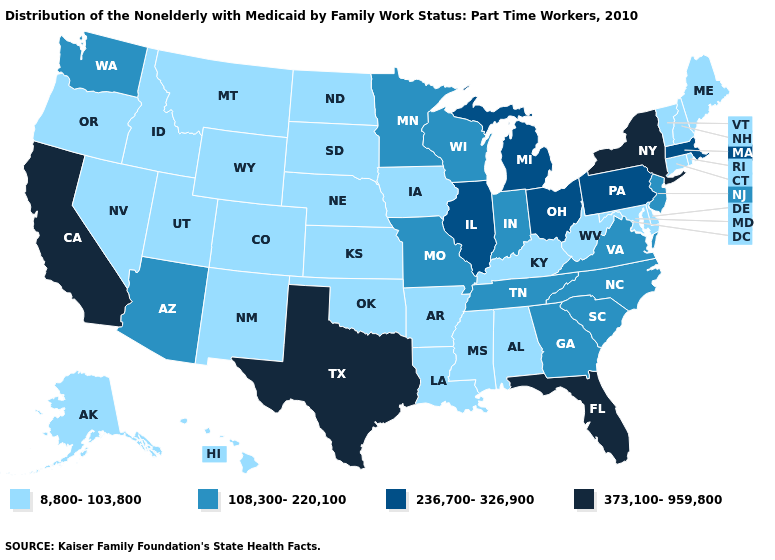What is the value of Idaho?
Write a very short answer. 8,800-103,800. Name the states that have a value in the range 108,300-220,100?
Keep it brief. Arizona, Georgia, Indiana, Minnesota, Missouri, New Jersey, North Carolina, South Carolina, Tennessee, Virginia, Washington, Wisconsin. Name the states that have a value in the range 236,700-326,900?
Quick response, please. Illinois, Massachusetts, Michigan, Ohio, Pennsylvania. What is the lowest value in states that border Kansas?
Answer briefly. 8,800-103,800. What is the value of New Jersey?
Be succinct. 108,300-220,100. Name the states that have a value in the range 8,800-103,800?
Be succinct. Alabama, Alaska, Arkansas, Colorado, Connecticut, Delaware, Hawaii, Idaho, Iowa, Kansas, Kentucky, Louisiana, Maine, Maryland, Mississippi, Montana, Nebraska, Nevada, New Hampshire, New Mexico, North Dakota, Oklahoma, Oregon, Rhode Island, South Dakota, Utah, Vermont, West Virginia, Wyoming. What is the highest value in the USA?
Be succinct. 373,100-959,800. What is the lowest value in the South?
Give a very brief answer. 8,800-103,800. Does Wisconsin have the same value as Minnesota?
Concise answer only. Yes. What is the value of West Virginia?
Be succinct. 8,800-103,800. Among the states that border Mississippi , does Tennessee have the highest value?
Concise answer only. Yes. How many symbols are there in the legend?
Be succinct. 4. Does Pennsylvania have a higher value than Illinois?
Answer briefly. No. What is the value of South Carolina?
Give a very brief answer. 108,300-220,100. Which states have the lowest value in the USA?
Write a very short answer. Alabama, Alaska, Arkansas, Colorado, Connecticut, Delaware, Hawaii, Idaho, Iowa, Kansas, Kentucky, Louisiana, Maine, Maryland, Mississippi, Montana, Nebraska, Nevada, New Hampshire, New Mexico, North Dakota, Oklahoma, Oregon, Rhode Island, South Dakota, Utah, Vermont, West Virginia, Wyoming. 